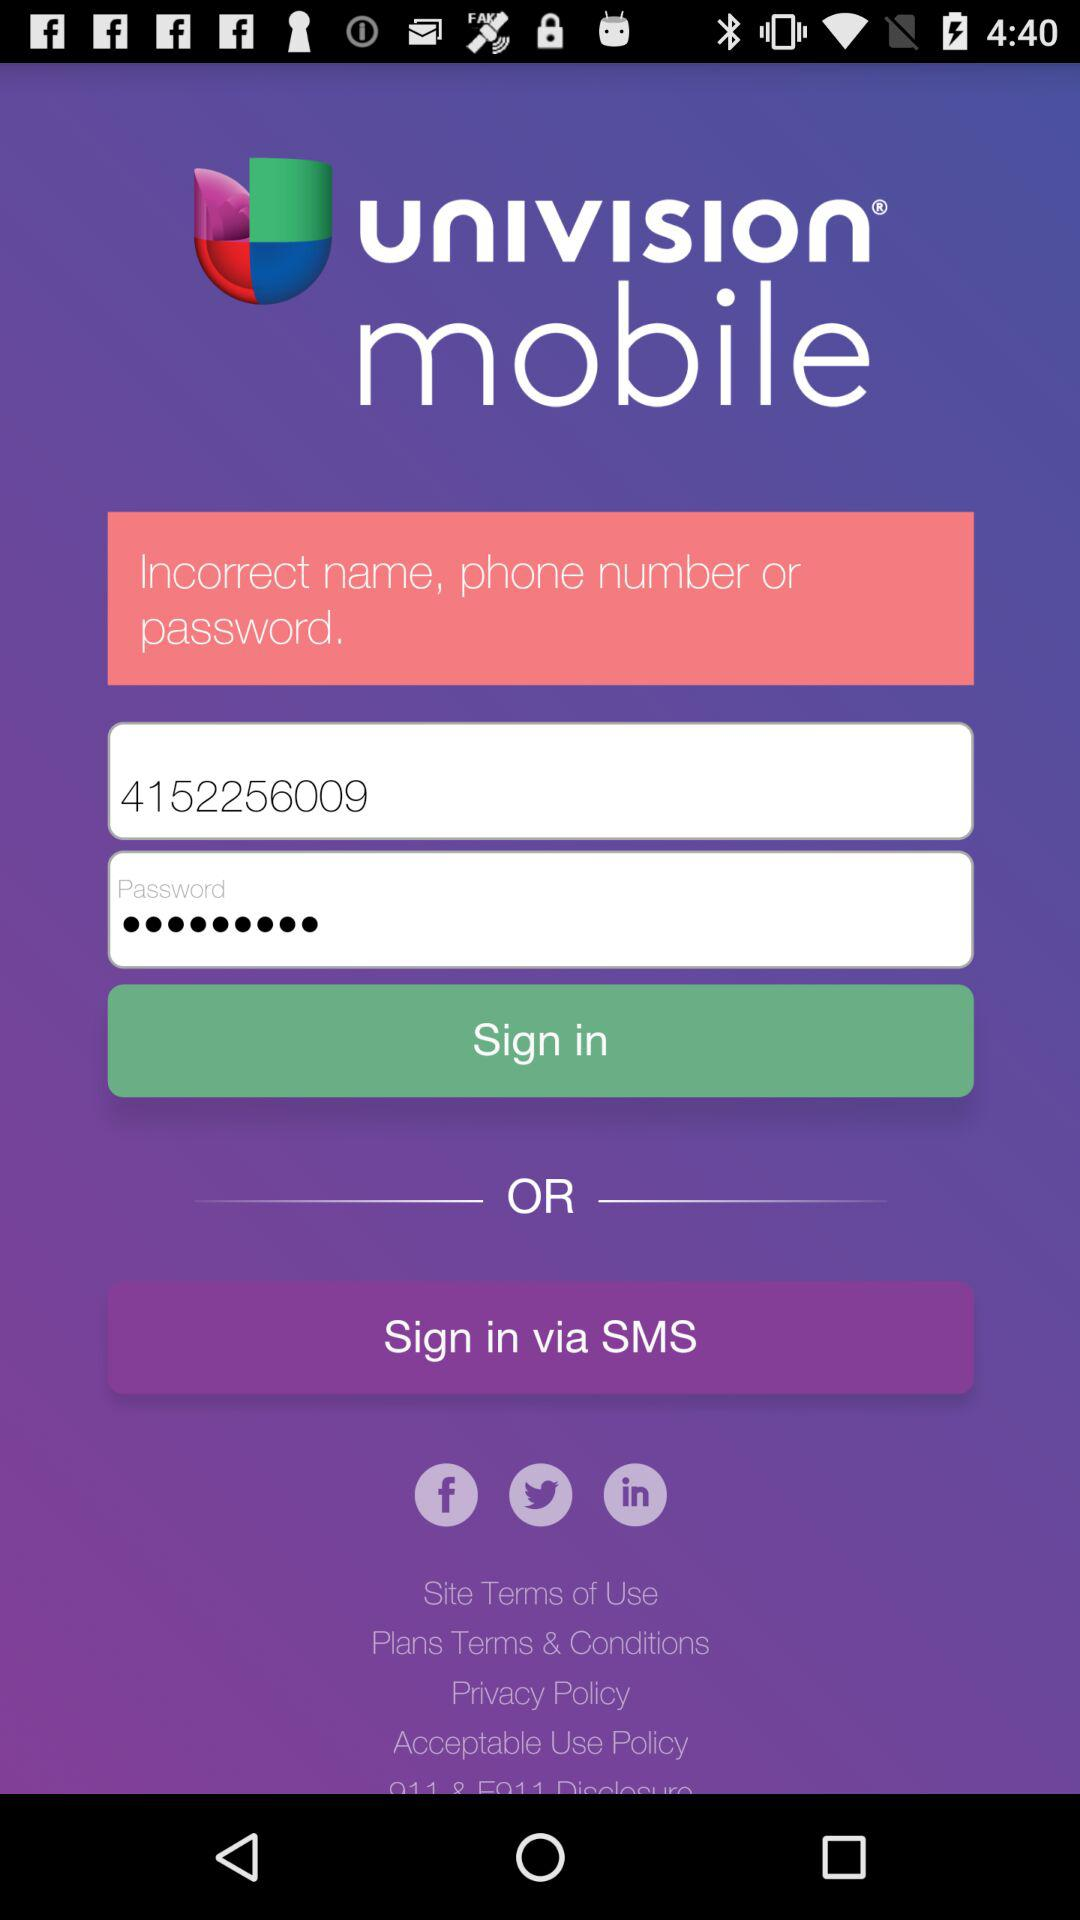What is the app title? The app title is "univision mobile". 